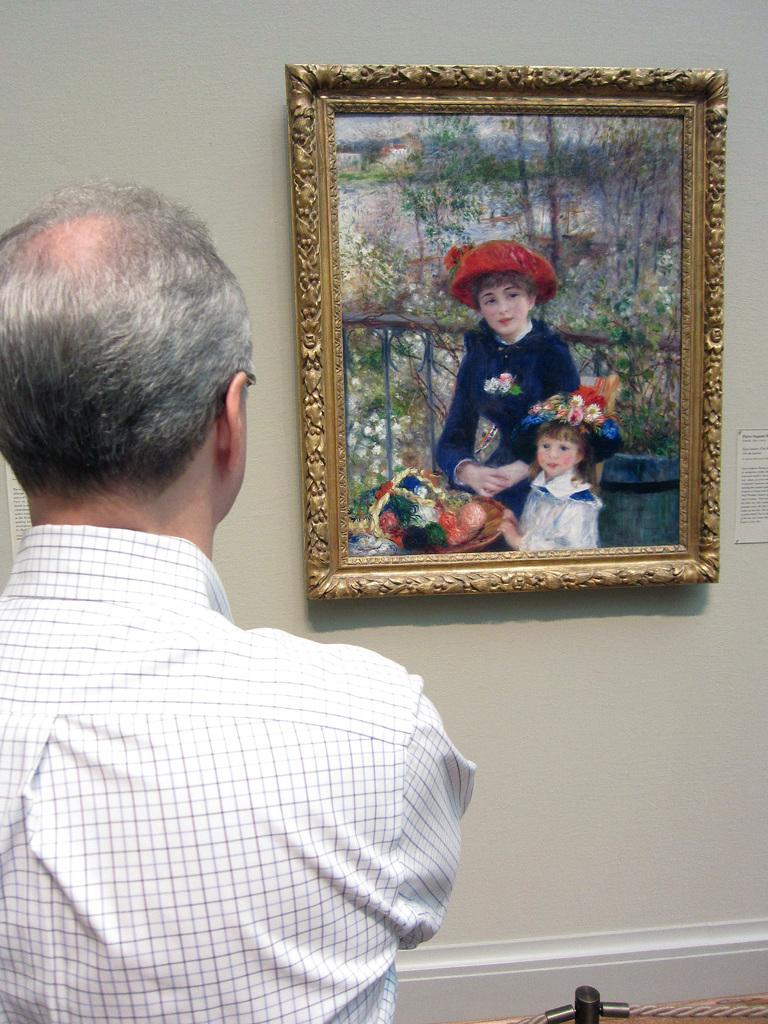What is attached to the wall in the image? There is a photo frame attached to the wall. What is the person in the image doing? The person is standing in front of the photo frame and watching it. What can be seen in the background of the image? There is a wall in the background. What type of crack is visible on the moon in the image? There is no moon or crack present in the image; it features a person standing in front of a photo frame attached to a wall. What is the stem used for in the image? There is no stem present in the image. 